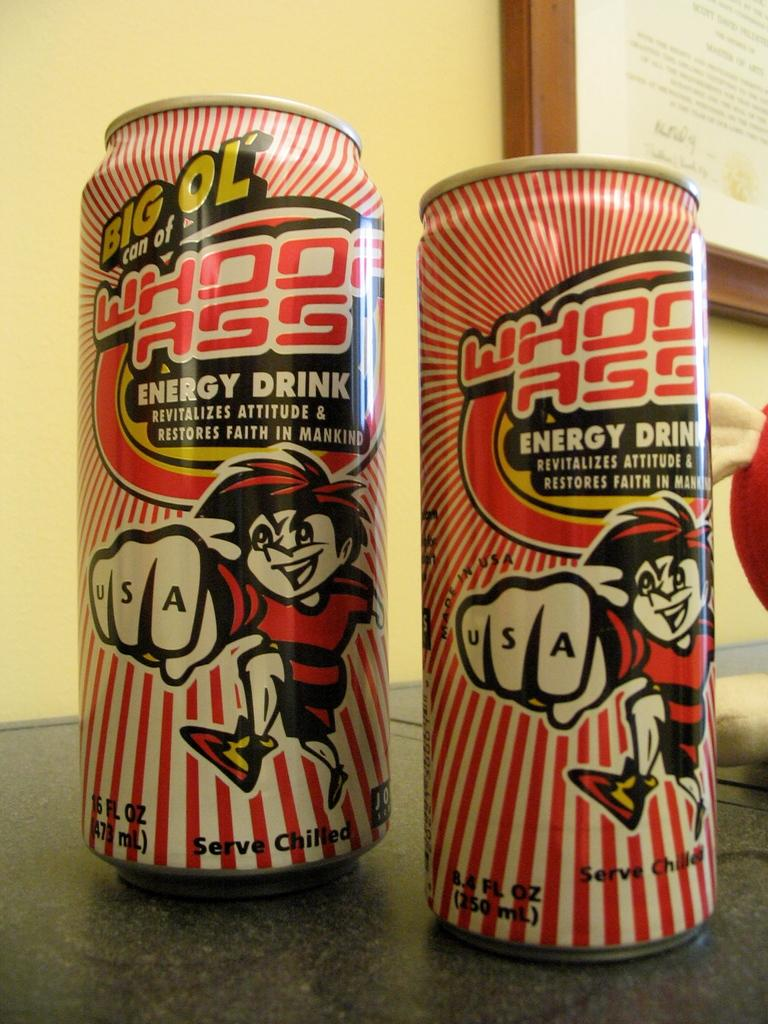<image>
Write a terse but informative summary of the picture. Two cans with a cartoon character showing USA written on his knuckles. 